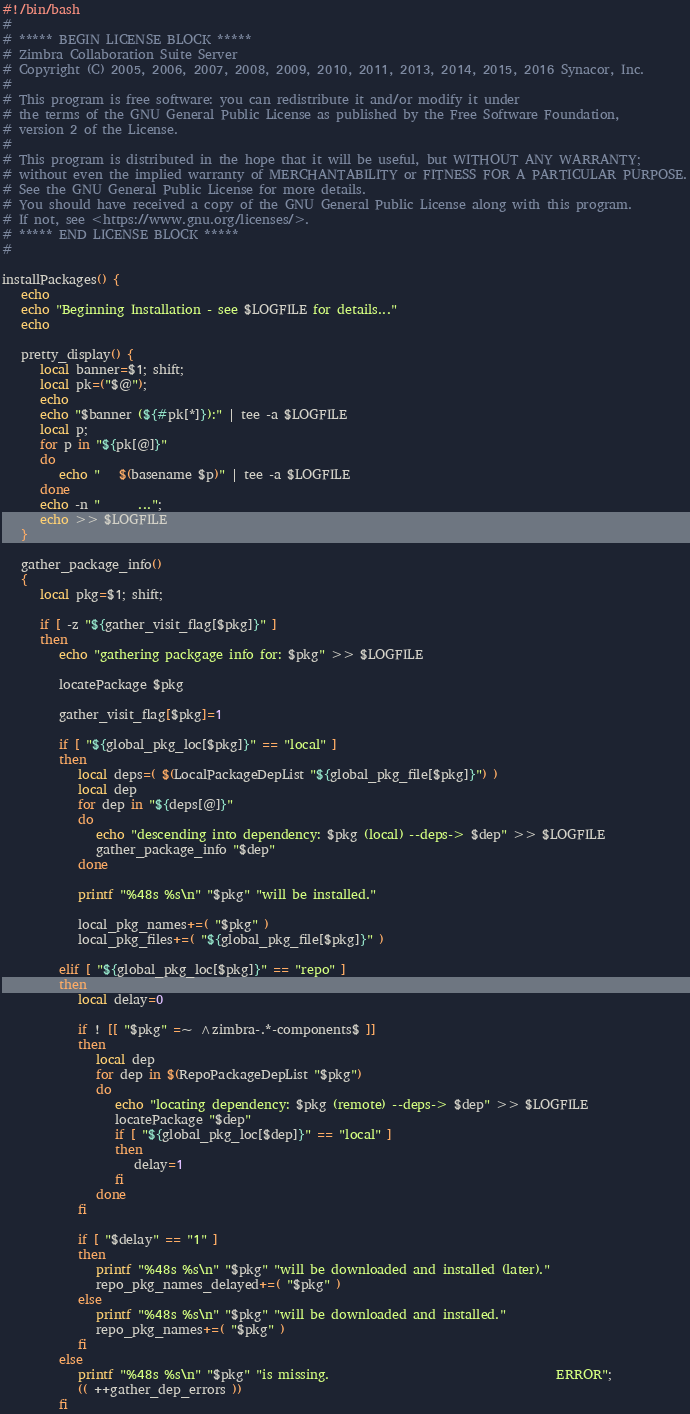Convert code to text. <code><loc_0><loc_0><loc_500><loc_500><_Bash_>#!/bin/bash
#
# ***** BEGIN LICENSE BLOCK *****
# Zimbra Collaboration Suite Server
# Copyright (C) 2005, 2006, 2007, 2008, 2009, 2010, 2011, 2013, 2014, 2015, 2016 Synacor, Inc.
#
# This program is free software: you can redistribute it and/or modify it under
# the terms of the GNU General Public License as published by the Free Software Foundation,
# version 2 of the License.
#
# This program is distributed in the hope that it will be useful, but WITHOUT ANY WARRANTY;
# without even the implied warranty of MERCHANTABILITY or FITNESS FOR A PARTICULAR PURPOSE.
# See the GNU General Public License for more details.
# You should have received a copy of the GNU General Public License along with this program.
# If not, see <https://www.gnu.org/licenses/>.
# ***** END LICENSE BLOCK *****
#

installPackages() {
   echo
   echo "Beginning Installation - see $LOGFILE for details..."
   echo

   pretty_display() {
      local banner=$1; shift;
      local pk=("$@");
      echo
      echo "$banner (${#pk[*]}):" | tee -a $LOGFILE
      local p;
      for p in "${pk[@]}"
      do
         echo "   $(basename $p)" | tee -a $LOGFILE
      done
      echo -n "      ...";
      echo >> $LOGFILE
   }

   gather_package_info()
   {
      local pkg=$1; shift;

      if [ -z "${gather_visit_flag[$pkg]}" ]
      then
         echo "gathering packgage info for: $pkg" >> $LOGFILE

         locatePackage $pkg

         gather_visit_flag[$pkg]=1

         if [ "${global_pkg_loc[$pkg]}" == "local" ]
         then
            local deps=( $(LocalPackageDepList "${global_pkg_file[$pkg]}") )
            local dep
            for dep in "${deps[@]}"
            do
               echo "descending into dependency: $pkg (local) --deps-> $dep" >> $LOGFILE
               gather_package_info "$dep"
            done

            printf "%48s %s\n" "$pkg" "will be installed."

            local_pkg_names+=( "$pkg" )
            local_pkg_files+=( "${global_pkg_file[$pkg]}" )

         elif [ "${global_pkg_loc[$pkg]}" == "repo" ]
         then
            local delay=0

            if ! [[ "$pkg" =~ ^zimbra-.*-components$ ]]
            then
               local dep
               for dep in $(RepoPackageDepList "$pkg")
               do
                  echo "locating dependency: $pkg (remote) --deps-> $dep" >> $LOGFILE
                  locatePackage "$dep"
                  if [ "${global_pkg_loc[$dep]}" == "local" ]
                  then
                     delay=1
                  fi
               done
            fi

            if [ "$delay" == "1" ]
            then
               printf "%48s %s\n" "$pkg" "will be downloaded and installed (later)."
               repo_pkg_names_delayed+=( "$pkg" )
            else
               printf "%48s %s\n" "$pkg" "will be downloaded and installed."
               repo_pkg_names+=( "$pkg" )
            fi
         else
            printf "%48s %s\n" "$pkg" "is missing.                                    ERROR";
            (( ++gather_dep_errors ))
         fi
</code> 